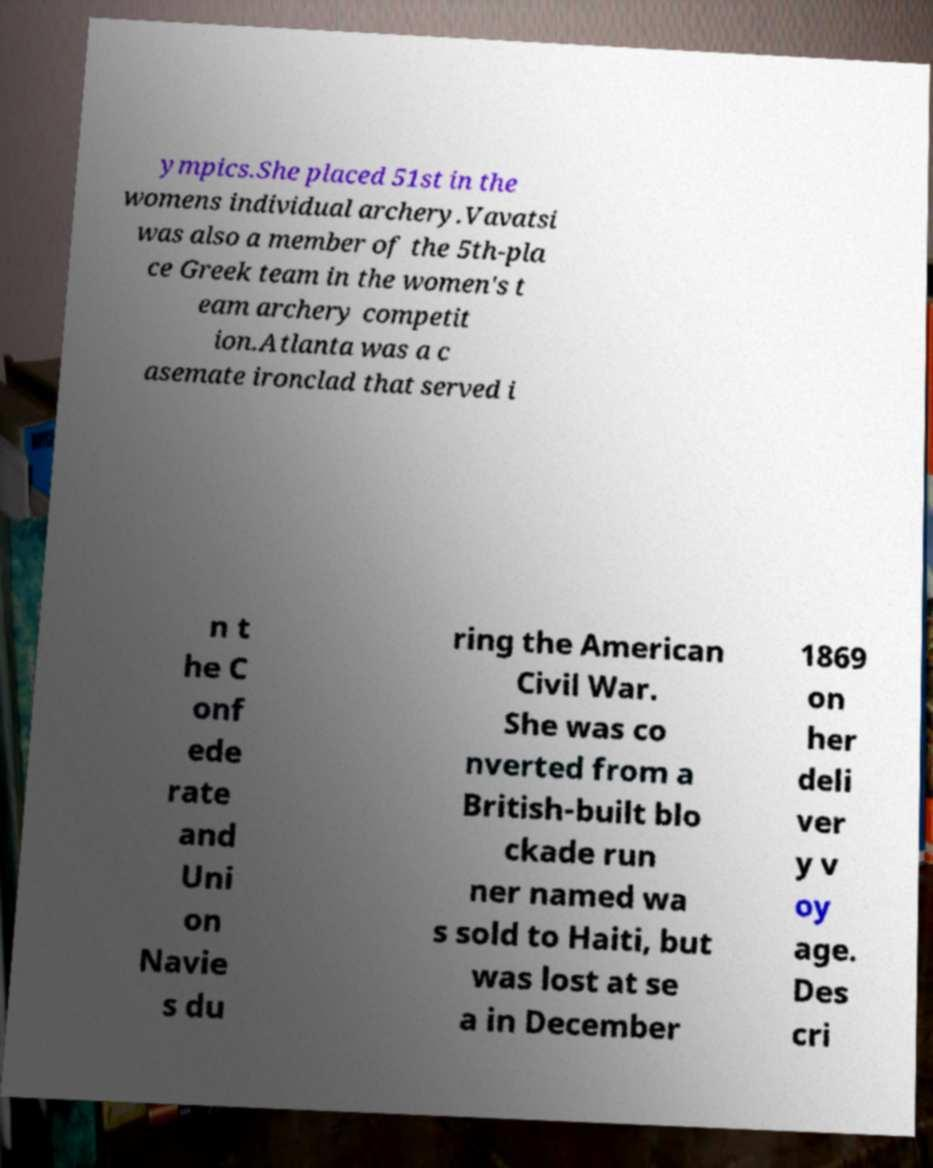Could you assist in decoding the text presented in this image and type it out clearly? ympics.She placed 51st in the womens individual archery.Vavatsi was also a member of the 5th-pla ce Greek team in the women's t eam archery competit ion.Atlanta was a c asemate ironclad that served i n t he C onf ede rate and Uni on Navie s du ring the American Civil War. She was co nverted from a British-built blo ckade run ner named wa s sold to Haiti, but was lost at se a in December 1869 on her deli ver y v oy age. Des cri 